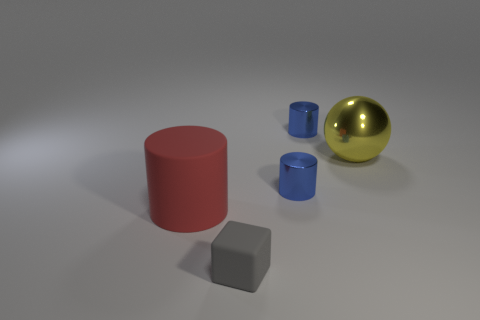Add 4 blue shiny things. How many objects exist? 9 Subtract all balls. How many objects are left? 4 Subtract all large cylinders. Subtract all small metal cylinders. How many objects are left? 2 Add 3 large metal balls. How many large metal balls are left? 4 Add 5 small green shiny objects. How many small green shiny objects exist? 5 Subtract 1 blue cylinders. How many objects are left? 4 